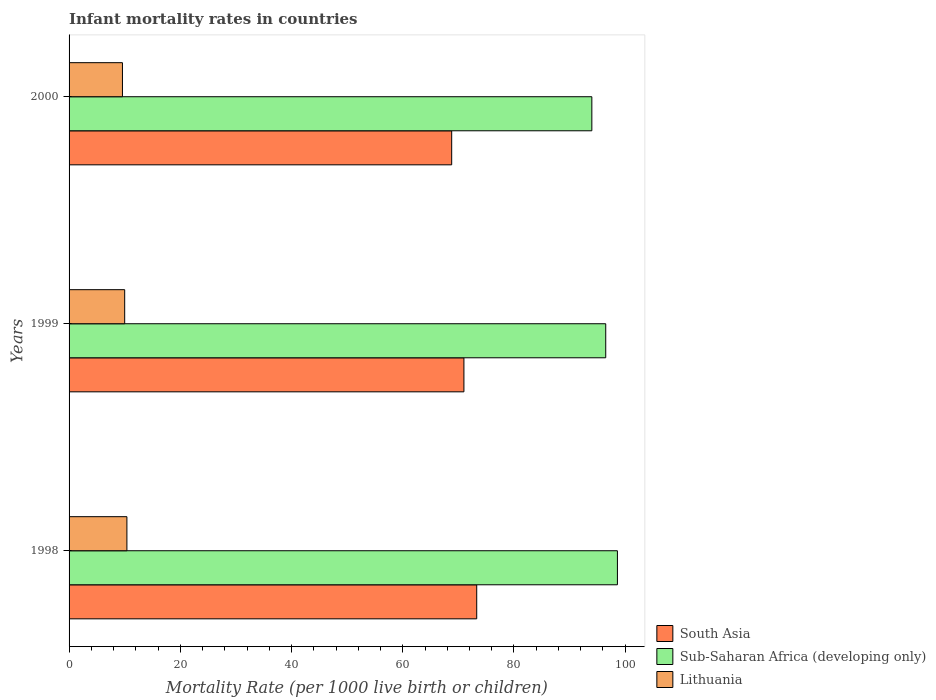How many groups of bars are there?
Give a very brief answer. 3. Are the number of bars on each tick of the Y-axis equal?
Your answer should be compact. Yes. What is the infant mortality rate in South Asia in 1998?
Offer a very short reply. 73.3. Across all years, what is the maximum infant mortality rate in Sub-Saharan Africa (developing only)?
Ensure brevity in your answer.  98.6. Across all years, what is the minimum infant mortality rate in Sub-Saharan Africa (developing only)?
Your answer should be compact. 94. In which year was the infant mortality rate in South Asia maximum?
Make the answer very short. 1998. In which year was the infant mortality rate in Sub-Saharan Africa (developing only) minimum?
Ensure brevity in your answer.  2000. What is the difference between the infant mortality rate in Sub-Saharan Africa (developing only) in 1998 and the infant mortality rate in South Asia in 1999?
Keep it short and to the point. 27.6. What is the average infant mortality rate in South Asia per year?
Ensure brevity in your answer.  71.03. In the year 2000, what is the difference between the infant mortality rate in South Asia and infant mortality rate in Lithuania?
Your response must be concise. 59.2. What is the ratio of the infant mortality rate in South Asia in 1998 to that in 1999?
Offer a very short reply. 1.03. Is the infant mortality rate in Lithuania in 1999 less than that in 2000?
Keep it short and to the point. No. What is the difference between the highest and the second highest infant mortality rate in South Asia?
Provide a short and direct response. 2.3. What is the difference between the highest and the lowest infant mortality rate in Sub-Saharan Africa (developing only)?
Ensure brevity in your answer.  4.6. In how many years, is the infant mortality rate in Sub-Saharan Africa (developing only) greater than the average infant mortality rate in Sub-Saharan Africa (developing only) taken over all years?
Your response must be concise. 2. What does the 2nd bar from the top in 1999 represents?
Your response must be concise. Sub-Saharan Africa (developing only). What does the 3rd bar from the bottom in 1999 represents?
Your answer should be very brief. Lithuania. Is it the case that in every year, the sum of the infant mortality rate in Lithuania and infant mortality rate in Sub-Saharan Africa (developing only) is greater than the infant mortality rate in South Asia?
Your response must be concise. Yes. How many bars are there?
Provide a short and direct response. 9. Are all the bars in the graph horizontal?
Give a very brief answer. Yes. How many years are there in the graph?
Provide a short and direct response. 3. What is the difference between two consecutive major ticks on the X-axis?
Keep it short and to the point. 20. Does the graph contain any zero values?
Make the answer very short. No. How are the legend labels stacked?
Make the answer very short. Vertical. What is the title of the graph?
Your answer should be very brief. Infant mortality rates in countries. What is the label or title of the X-axis?
Give a very brief answer. Mortality Rate (per 1000 live birth or children). What is the label or title of the Y-axis?
Make the answer very short. Years. What is the Mortality Rate (per 1000 live birth or children) in South Asia in 1998?
Keep it short and to the point. 73.3. What is the Mortality Rate (per 1000 live birth or children) in Sub-Saharan Africa (developing only) in 1998?
Ensure brevity in your answer.  98.6. What is the Mortality Rate (per 1000 live birth or children) in South Asia in 1999?
Ensure brevity in your answer.  71. What is the Mortality Rate (per 1000 live birth or children) of Sub-Saharan Africa (developing only) in 1999?
Offer a terse response. 96.5. What is the Mortality Rate (per 1000 live birth or children) of Lithuania in 1999?
Give a very brief answer. 10. What is the Mortality Rate (per 1000 live birth or children) of South Asia in 2000?
Your answer should be compact. 68.8. What is the Mortality Rate (per 1000 live birth or children) in Sub-Saharan Africa (developing only) in 2000?
Make the answer very short. 94. What is the Mortality Rate (per 1000 live birth or children) of Lithuania in 2000?
Make the answer very short. 9.6. Across all years, what is the maximum Mortality Rate (per 1000 live birth or children) of South Asia?
Keep it short and to the point. 73.3. Across all years, what is the maximum Mortality Rate (per 1000 live birth or children) in Sub-Saharan Africa (developing only)?
Provide a succinct answer. 98.6. Across all years, what is the minimum Mortality Rate (per 1000 live birth or children) of South Asia?
Make the answer very short. 68.8. Across all years, what is the minimum Mortality Rate (per 1000 live birth or children) of Sub-Saharan Africa (developing only)?
Give a very brief answer. 94. What is the total Mortality Rate (per 1000 live birth or children) in South Asia in the graph?
Provide a short and direct response. 213.1. What is the total Mortality Rate (per 1000 live birth or children) of Sub-Saharan Africa (developing only) in the graph?
Make the answer very short. 289.1. What is the difference between the Mortality Rate (per 1000 live birth or children) in South Asia in 1998 and that in 1999?
Your response must be concise. 2.3. What is the difference between the Mortality Rate (per 1000 live birth or children) in Sub-Saharan Africa (developing only) in 1998 and that in 1999?
Provide a short and direct response. 2.1. What is the difference between the Mortality Rate (per 1000 live birth or children) in Lithuania in 1998 and that in 1999?
Offer a terse response. 0.4. What is the difference between the Mortality Rate (per 1000 live birth or children) of Lithuania in 1998 and that in 2000?
Offer a terse response. 0.8. What is the difference between the Mortality Rate (per 1000 live birth or children) of South Asia in 1999 and that in 2000?
Give a very brief answer. 2.2. What is the difference between the Mortality Rate (per 1000 live birth or children) of Sub-Saharan Africa (developing only) in 1999 and that in 2000?
Ensure brevity in your answer.  2.5. What is the difference between the Mortality Rate (per 1000 live birth or children) of Lithuania in 1999 and that in 2000?
Offer a very short reply. 0.4. What is the difference between the Mortality Rate (per 1000 live birth or children) in South Asia in 1998 and the Mortality Rate (per 1000 live birth or children) in Sub-Saharan Africa (developing only) in 1999?
Keep it short and to the point. -23.2. What is the difference between the Mortality Rate (per 1000 live birth or children) in South Asia in 1998 and the Mortality Rate (per 1000 live birth or children) in Lithuania in 1999?
Ensure brevity in your answer.  63.3. What is the difference between the Mortality Rate (per 1000 live birth or children) in Sub-Saharan Africa (developing only) in 1998 and the Mortality Rate (per 1000 live birth or children) in Lithuania in 1999?
Your answer should be compact. 88.6. What is the difference between the Mortality Rate (per 1000 live birth or children) of South Asia in 1998 and the Mortality Rate (per 1000 live birth or children) of Sub-Saharan Africa (developing only) in 2000?
Your response must be concise. -20.7. What is the difference between the Mortality Rate (per 1000 live birth or children) of South Asia in 1998 and the Mortality Rate (per 1000 live birth or children) of Lithuania in 2000?
Keep it short and to the point. 63.7. What is the difference between the Mortality Rate (per 1000 live birth or children) in Sub-Saharan Africa (developing only) in 1998 and the Mortality Rate (per 1000 live birth or children) in Lithuania in 2000?
Your answer should be very brief. 89. What is the difference between the Mortality Rate (per 1000 live birth or children) of South Asia in 1999 and the Mortality Rate (per 1000 live birth or children) of Lithuania in 2000?
Offer a terse response. 61.4. What is the difference between the Mortality Rate (per 1000 live birth or children) in Sub-Saharan Africa (developing only) in 1999 and the Mortality Rate (per 1000 live birth or children) in Lithuania in 2000?
Offer a terse response. 86.9. What is the average Mortality Rate (per 1000 live birth or children) of South Asia per year?
Your answer should be compact. 71.03. What is the average Mortality Rate (per 1000 live birth or children) in Sub-Saharan Africa (developing only) per year?
Provide a short and direct response. 96.37. What is the average Mortality Rate (per 1000 live birth or children) in Lithuania per year?
Keep it short and to the point. 10. In the year 1998, what is the difference between the Mortality Rate (per 1000 live birth or children) in South Asia and Mortality Rate (per 1000 live birth or children) in Sub-Saharan Africa (developing only)?
Keep it short and to the point. -25.3. In the year 1998, what is the difference between the Mortality Rate (per 1000 live birth or children) in South Asia and Mortality Rate (per 1000 live birth or children) in Lithuania?
Your answer should be very brief. 62.9. In the year 1998, what is the difference between the Mortality Rate (per 1000 live birth or children) of Sub-Saharan Africa (developing only) and Mortality Rate (per 1000 live birth or children) of Lithuania?
Provide a succinct answer. 88.2. In the year 1999, what is the difference between the Mortality Rate (per 1000 live birth or children) of South Asia and Mortality Rate (per 1000 live birth or children) of Sub-Saharan Africa (developing only)?
Ensure brevity in your answer.  -25.5. In the year 1999, what is the difference between the Mortality Rate (per 1000 live birth or children) in South Asia and Mortality Rate (per 1000 live birth or children) in Lithuania?
Ensure brevity in your answer.  61. In the year 1999, what is the difference between the Mortality Rate (per 1000 live birth or children) of Sub-Saharan Africa (developing only) and Mortality Rate (per 1000 live birth or children) of Lithuania?
Make the answer very short. 86.5. In the year 2000, what is the difference between the Mortality Rate (per 1000 live birth or children) in South Asia and Mortality Rate (per 1000 live birth or children) in Sub-Saharan Africa (developing only)?
Make the answer very short. -25.2. In the year 2000, what is the difference between the Mortality Rate (per 1000 live birth or children) of South Asia and Mortality Rate (per 1000 live birth or children) of Lithuania?
Give a very brief answer. 59.2. In the year 2000, what is the difference between the Mortality Rate (per 1000 live birth or children) of Sub-Saharan Africa (developing only) and Mortality Rate (per 1000 live birth or children) of Lithuania?
Provide a succinct answer. 84.4. What is the ratio of the Mortality Rate (per 1000 live birth or children) of South Asia in 1998 to that in 1999?
Your answer should be very brief. 1.03. What is the ratio of the Mortality Rate (per 1000 live birth or children) of Sub-Saharan Africa (developing only) in 1998 to that in 1999?
Your response must be concise. 1.02. What is the ratio of the Mortality Rate (per 1000 live birth or children) in Lithuania in 1998 to that in 1999?
Provide a succinct answer. 1.04. What is the ratio of the Mortality Rate (per 1000 live birth or children) in South Asia in 1998 to that in 2000?
Give a very brief answer. 1.07. What is the ratio of the Mortality Rate (per 1000 live birth or children) of Sub-Saharan Africa (developing only) in 1998 to that in 2000?
Provide a short and direct response. 1.05. What is the ratio of the Mortality Rate (per 1000 live birth or children) in South Asia in 1999 to that in 2000?
Give a very brief answer. 1.03. What is the ratio of the Mortality Rate (per 1000 live birth or children) of Sub-Saharan Africa (developing only) in 1999 to that in 2000?
Provide a short and direct response. 1.03. What is the ratio of the Mortality Rate (per 1000 live birth or children) of Lithuania in 1999 to that in 2000?
Provide a short and direct response. 1.04. What is the difference between the highest and the second highest Mortality Rate (per 1000 live birth or children) of South Asia?
Provide a short and direct response. 2.3. What is the difference between the highest and the second highest Mortality Rate (per 1000 live birth or children) of Sub-Saharan Africa (developing only)?
Ensure brevity in your answer.  2.1. What is the difference between the highest and the second highest Mortality Rate (per 1000 live birth or children) of Lithuania?
Provide a short and direct response. 0.4. What is the difference between the highest and the lowest Mortality Rate (per 1000 live birth or children) of Lithuania?
Offer a terse response. 0.8. 